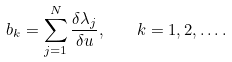Convert formula to latex. <formula><loc_0><loc_0><loc_500><loc_500>b _ { k } = \sum _ { j = 1 } ^ { N } \frac { \delta \lambda _ { j } } { \delta u } , \quad k = 1 , 2 , \dots .</formula> 